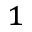Convert formula to latex. <formula><loc_0><loc_0><loc_500><loc_500>^ { 1 }</formula> 